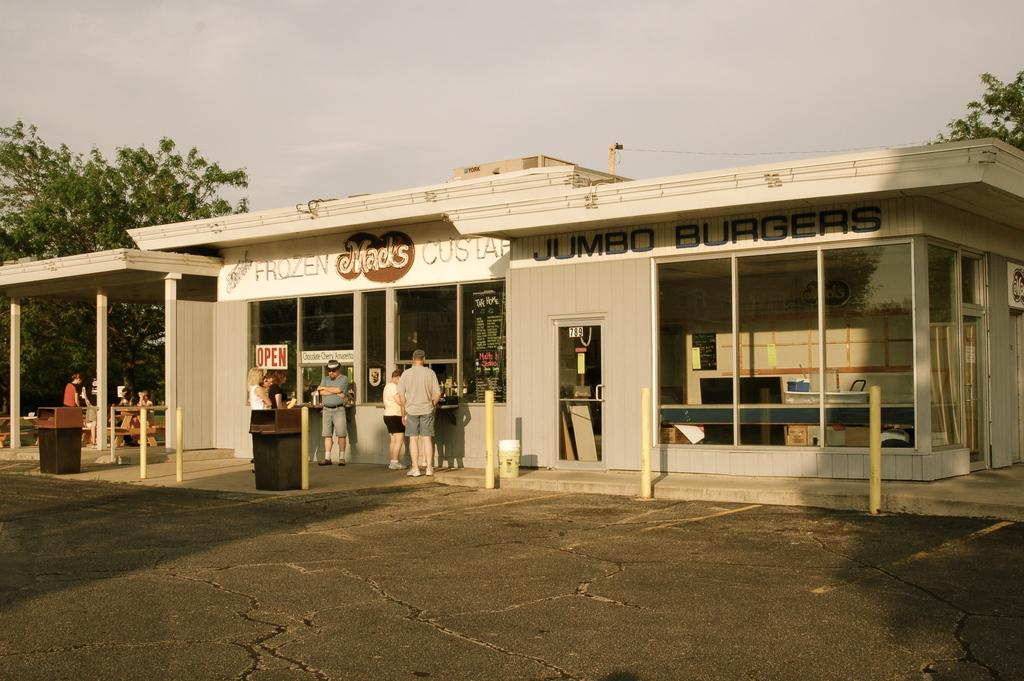What is the main structure in the center of the image? There is a building in the center of the image. What is located near the building? There is a counter in the image. Are there any people present in the image? Yes, there are people standing in the image. What objects can be used for waste disposal in the image? There are bins in the image. What can be seen in the background of the image? There are trees and the sky visible in the background of the image. What type of apple is being used as a decoration on the counter in the image? There is no apple present in the image; it features a building, counter, people, bins, trees, and sky. What religious symbols can be seen in the image? There are no religious symbols present in the image. 